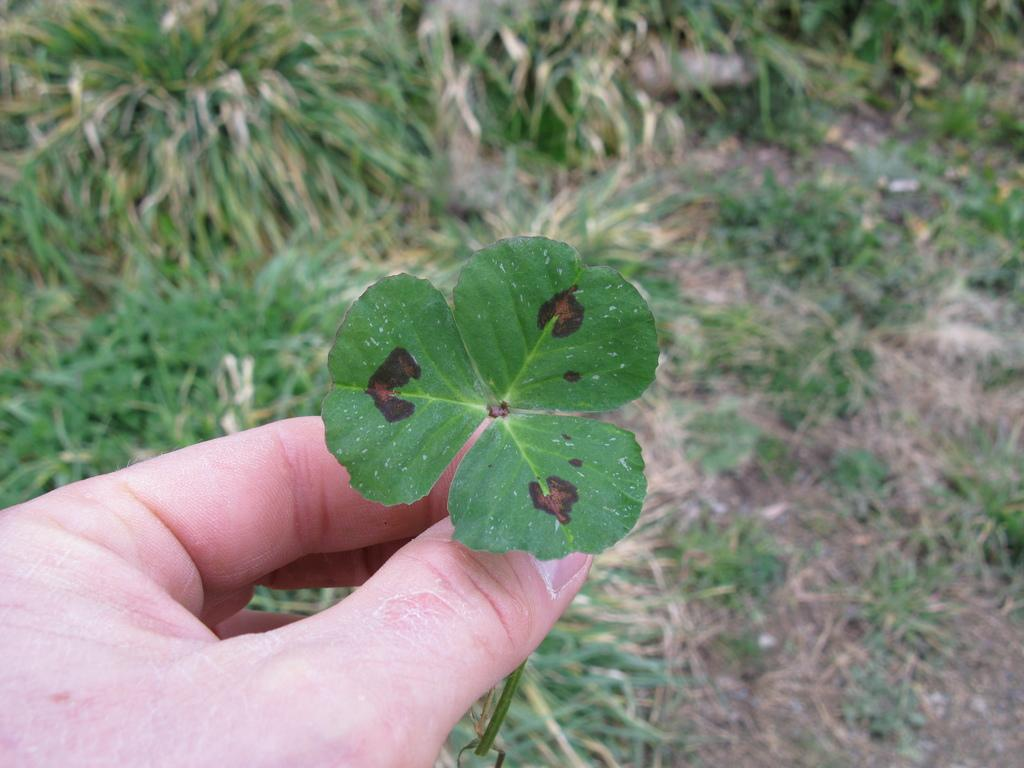Where was the picture taken? The picture was clicked outside. What is the person in the image doing? The person is holding leaves in the image. Which part of the person is visible in the image? The hand of the person is visible. What else can be seen in the image besides the person? There are leaves and grass in the background of the image. What is visible on the ground in the image? The ground is visible in the background of the image. What type of scarf is the person wearing in the image? There is no scarf visible in the image; the person is holding leaves. What historical event is depicted in the image? There is no historical event depicted in the image; it shows a person holding leaves outside. 